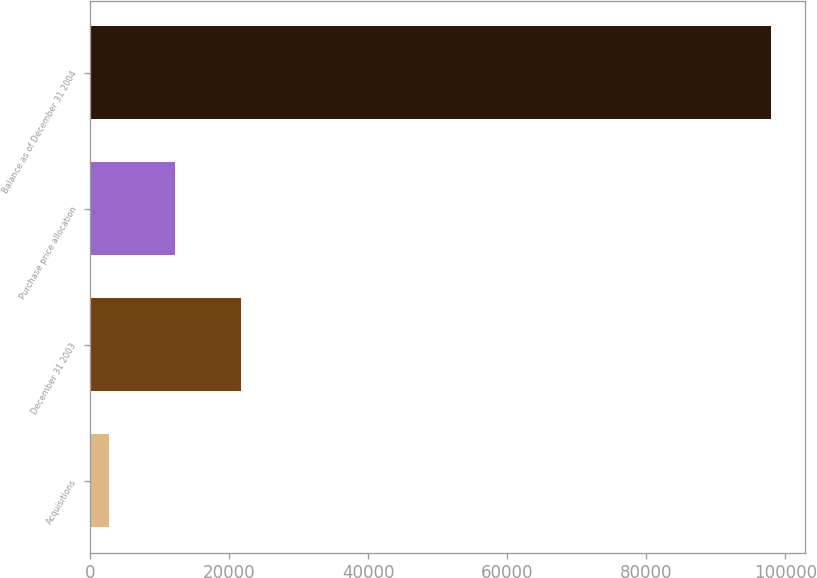Convert chart to OTSL. <chart><loc_0><loc_0><loc_500><loc_500><bar_chart><fcel>Acquisitions<fcel>December 31 2003<fcel>Purchase price allocation<fcel>Balance as of December 31 2004<nl><fcel>2628<fcel>21680.6<fcel>12154.3<fcel>97891<nl></chart> 